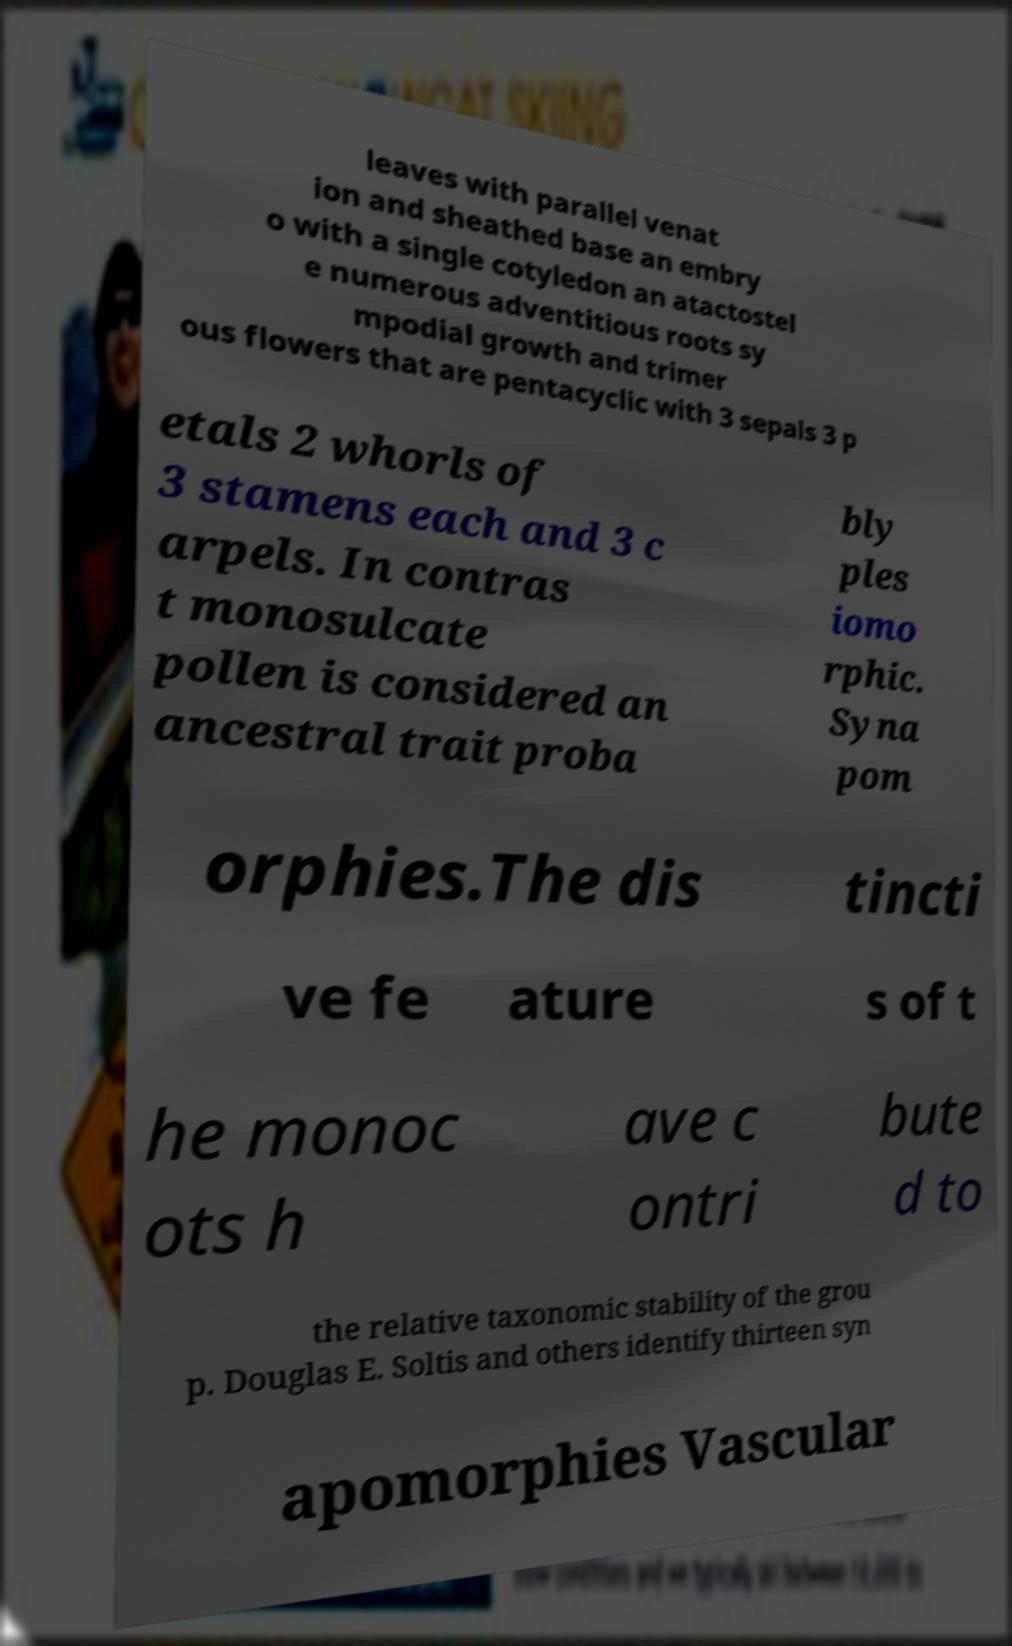Could you assist in decoding the text presented in this image and type it out clearly? leaves with parallel venat ion and sheathed base an embry o with a single cotyledon an atactostel e numerous adventitious roots sy mpodial growth and trimer ous flowers that are pentacyclic with 3 sepals 3 p etals 2 whorls of 3 stamens each and 3 c arpels. In contras t monosulcate pollen is considered an ancestral trait proba bly ples iomo rphic. Syna pom orphies.The dis tincti ve fe ature s of t he monoc ots h ave c ontri bute d to the relative taxonomic stability of the grou p. Douglas E. Soltis and others identify thirteen syn apomorphies Vascular 